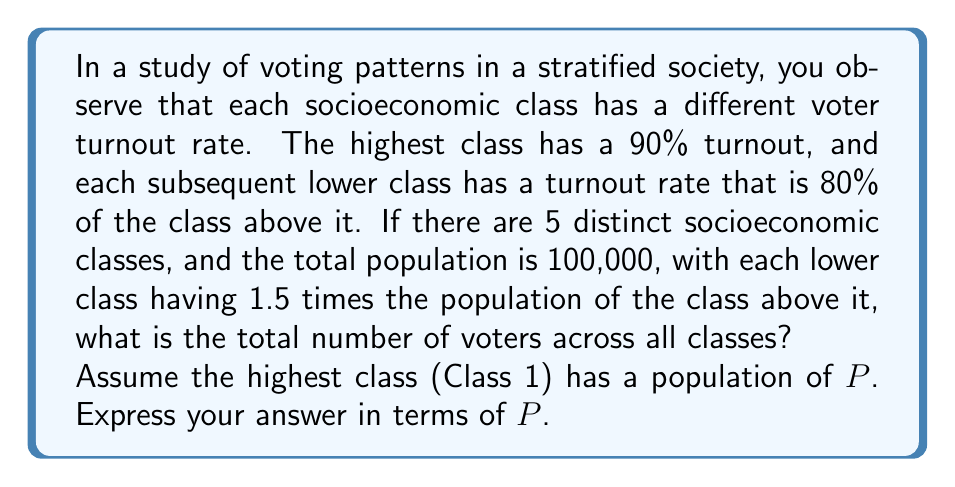Show me your answer to this math problem. Let's approach this step-by-step:

1) First, let's define our geometric series for voter turnout rates:
   Class 1: 90%
   Class 2: 90% * 0.8 = 72%
   Class 3: 72% * 0.8 = 57.6%
   Class 4: 57.6% * 0.8 = 46.08%
   Class 5: 46.08% * 0.8 = 36.864%

2) Now, let's define the population for each class:
   Class 1: $P$
   Class 2: $1.5P$
   Class 3: $1.5^2P = 2.25P$
   Class 4: $1.5^3P = 3.375P$
   Class 5: $1.5^4P = 5.0625P$

3) The total population is 100,000, so:
   $P + 1.5P + 2.25P + 3.375P + 5.0625P = 100,000$
   $13.1875P = 100,000$
   $P = 7,583.97$ (rounded to 2 decimal places)

4) Now, let's calculate the number of voters in each class:
   Class 1: $0.90 * P = 0.90P$
   Class 2: $0.72 * 1.5P = 1.08P$
   Class 3: $0.576 * 2.25P = 1.296P$
   Class 4: $0.4608 * 3.375P = 1.5552P$
   Class 5: $0.36864 * 5.0625P = 1.86624P$

5) The total number of voters is the sum of voters from all classes:
   $0.90P + 1.08P + 1.296P + 1.5552P + 1.86624P = 6.69344P$

Therefore, the total number of voters across all classes is $6.69344P$.
Answer: $6.69344P$ voters 